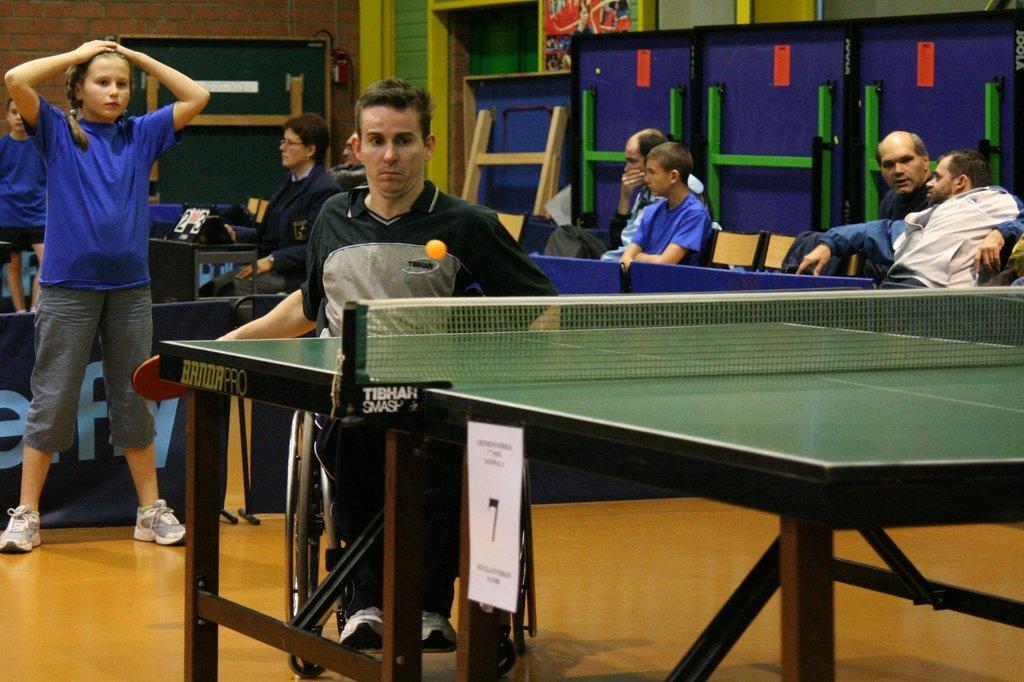Could you give a brief overview of what you see in this image? This picture shows all the people seated on the chairs and we see a man seated on the wheelchair and playing table tennis and we see a woman standing on his back 